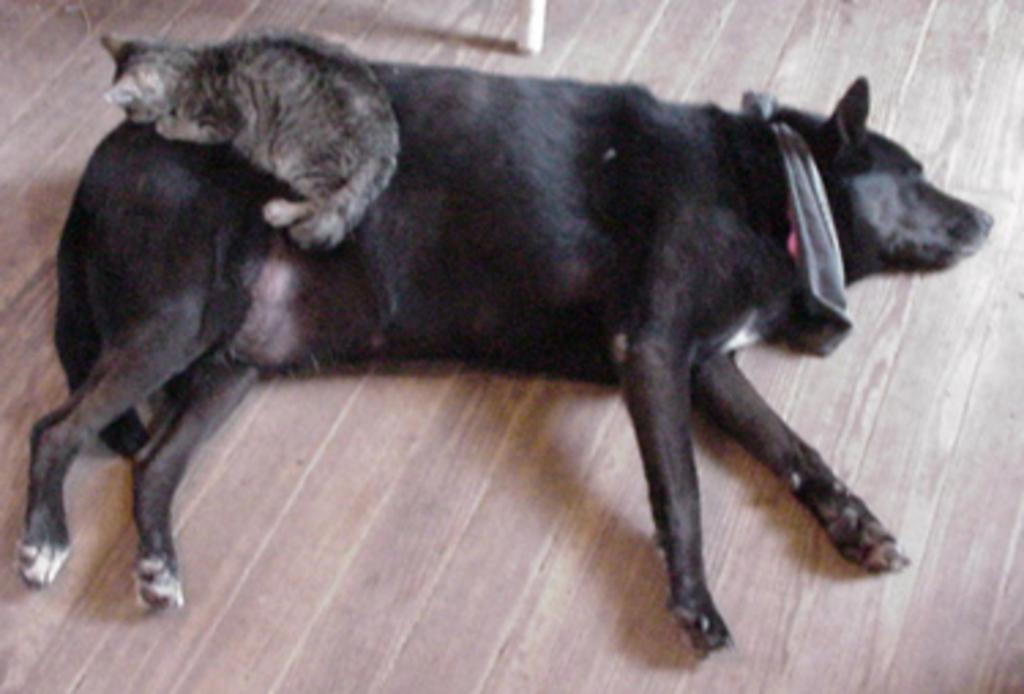What type of animal can be seen in the image? There is a dog in the image. What is the surface on which the dog is lying? The dog is lying on a wooden floor. Are there any other animals present in the image? Yes, there is a cat in the image. How is the cat positioned in relation to the dog? The cat is lying on the dog. What type of jewel is the dog wearing on its elbow in the image? There is no jewel present in the image, and the dog does not have an elbow. 